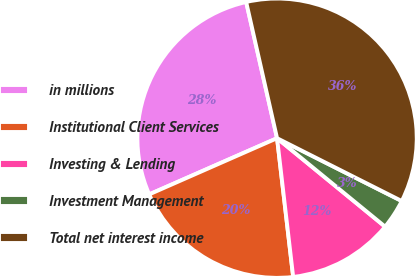<chart> <loc_0><loc_0><loc_500><loc_500><pie_chart><fcel>in millions<fcel>Institutional Client Services<fcel>Investing & Lending<fcel>Investment Management<fcel>Total net interest income<nl><fcel>28.04%<fcel>20.25%<fcel>12.24%<fcel>3.49%<fcel>35.98%<nl></chart> 